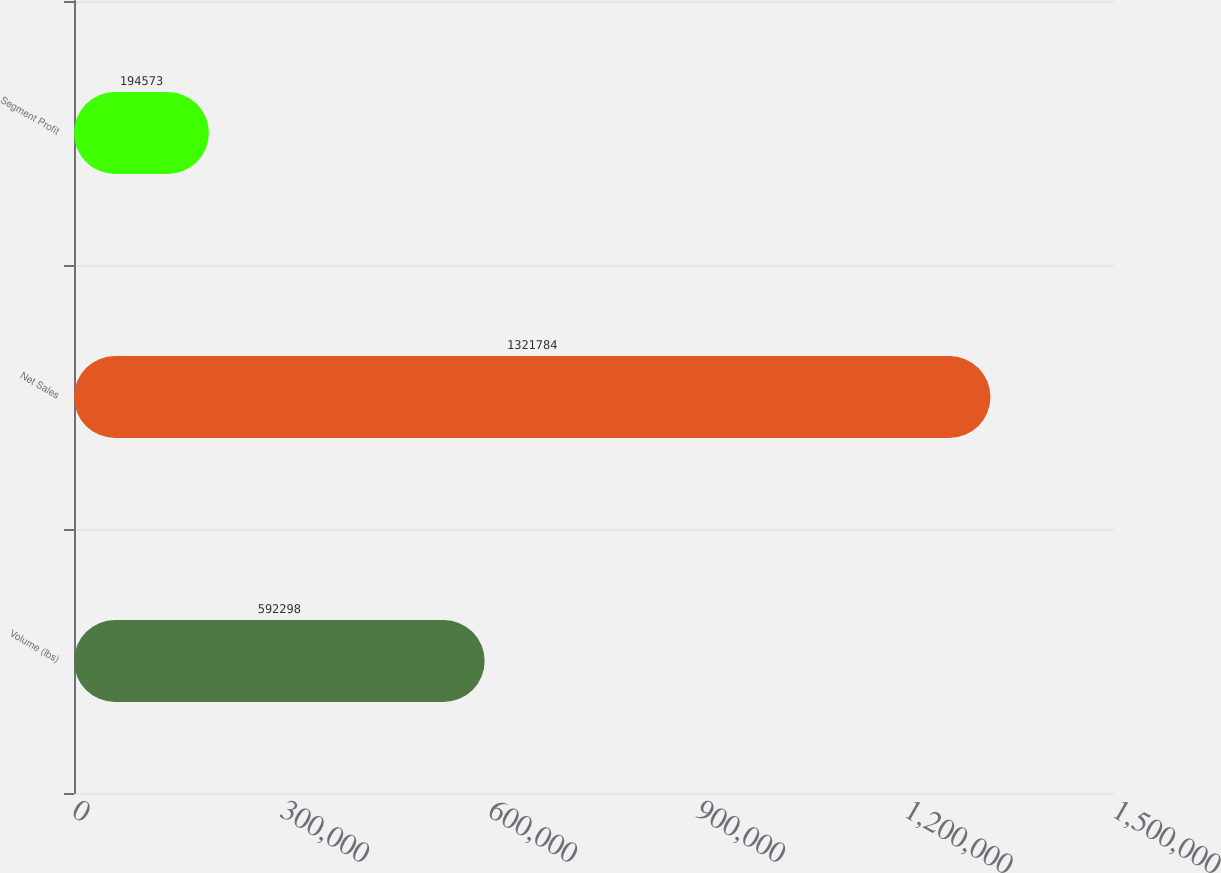Convert chart. <chart><loc_0><loc_0><loc_500><loc_500><bar_chart><fcel>Volume (lbs)<fcel>Net Sales<fcel>Segment Profit<nl><fcel>592298<fcel>1.32178e+06<fcel>194573<nl></chart> 